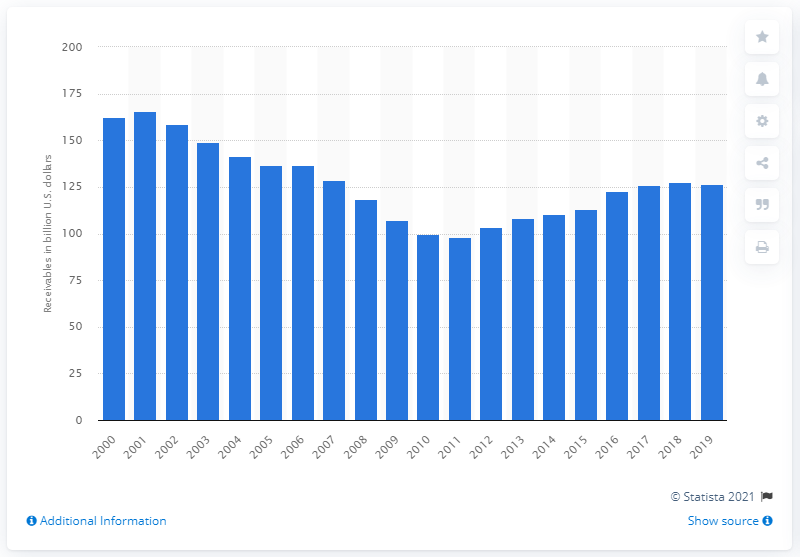Outline some significant characteristics in this image. The value of lease financing receivables of FDIC-insured commercial banks in 2019 was 126.34 billion dollars. 